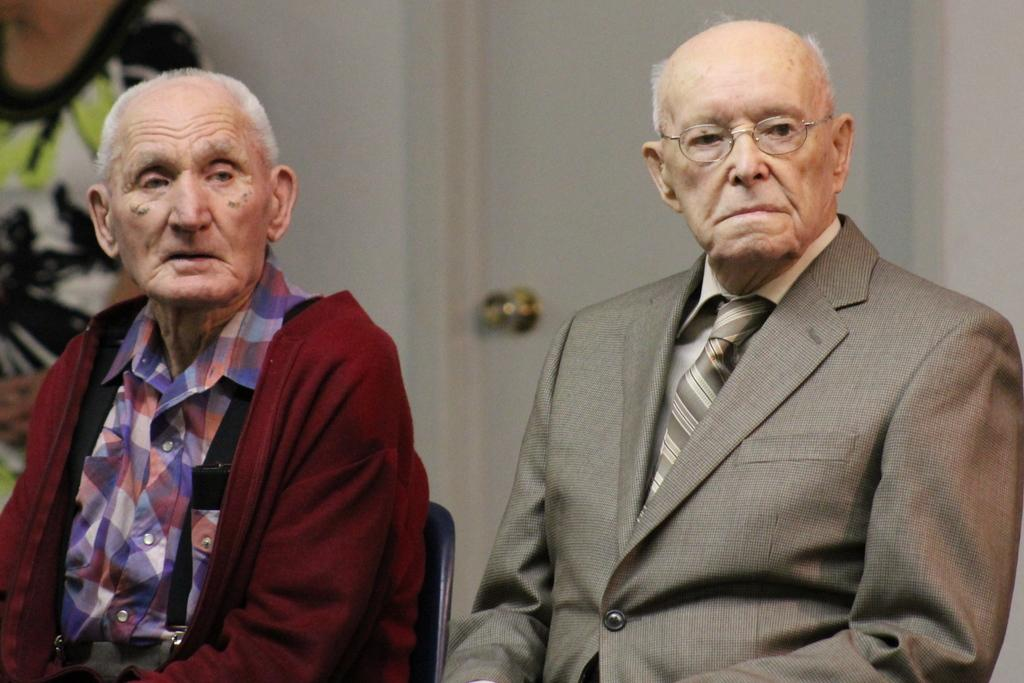What are the two old men doing in the image? The two old men are sitting on chairs in the image. Can you describe the person standing in the image? There is a person standing in the image, but no specific details about their appearance or actions are provided. What can be seen in the background of the image? There is a door with a door handle in the background of the image. What type of locket is the person wearing in the image? There is no person wearing a locket in the image. How does the person standing in the image feel about their actions? We cannot determine the person's feelings or emotions based on the provided facts. What type of soda is being served in the image? There is no mention of soda or any beverage in the image. 